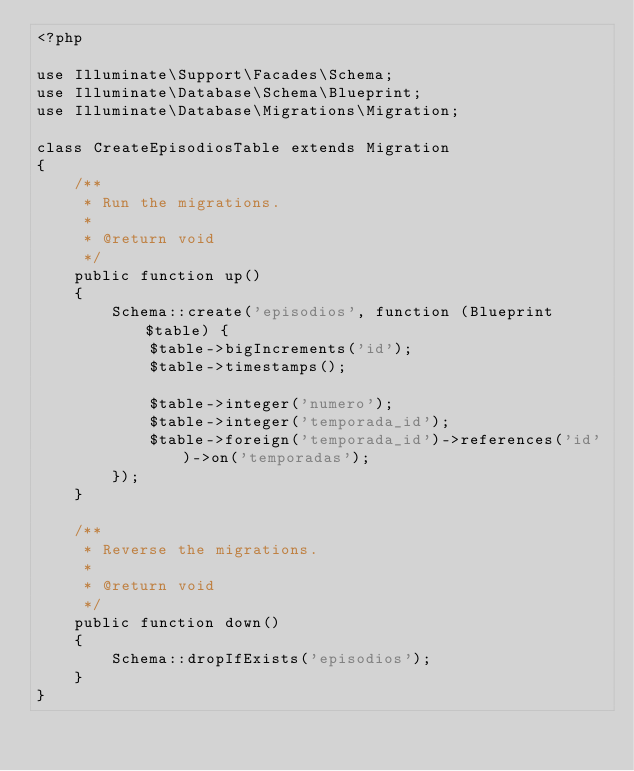<code> <loc_0><loc_0><loc_500><loc_500><_PHP_><?php

use Illuminate\Support\Facades\Schema;
use Illuminate\Database\Schema\Blueprint;
use Illuminate\Database\Migrations\Migration;

class CreateEpisodiosTable extends Migration
{
    /**
     * Run the migrations.
     *
     * @return void
     */
    public function up()
    {
        Schema::create('episodios', function (Blueprint $table) {
            $table->bigIncrements('id');
            $table->timestamps();

            $table->integer('numero');
            $table->integer('temporada_id');
            $table->foreign('temporada_id')->references('id')->on('temporadas');
        });
    }

    /**
     * Reverse the migrations.
     *
     * @return void
     */
    public function down()
    {
        Schema::dropIfExists('episodios');
    }
}
</code> 